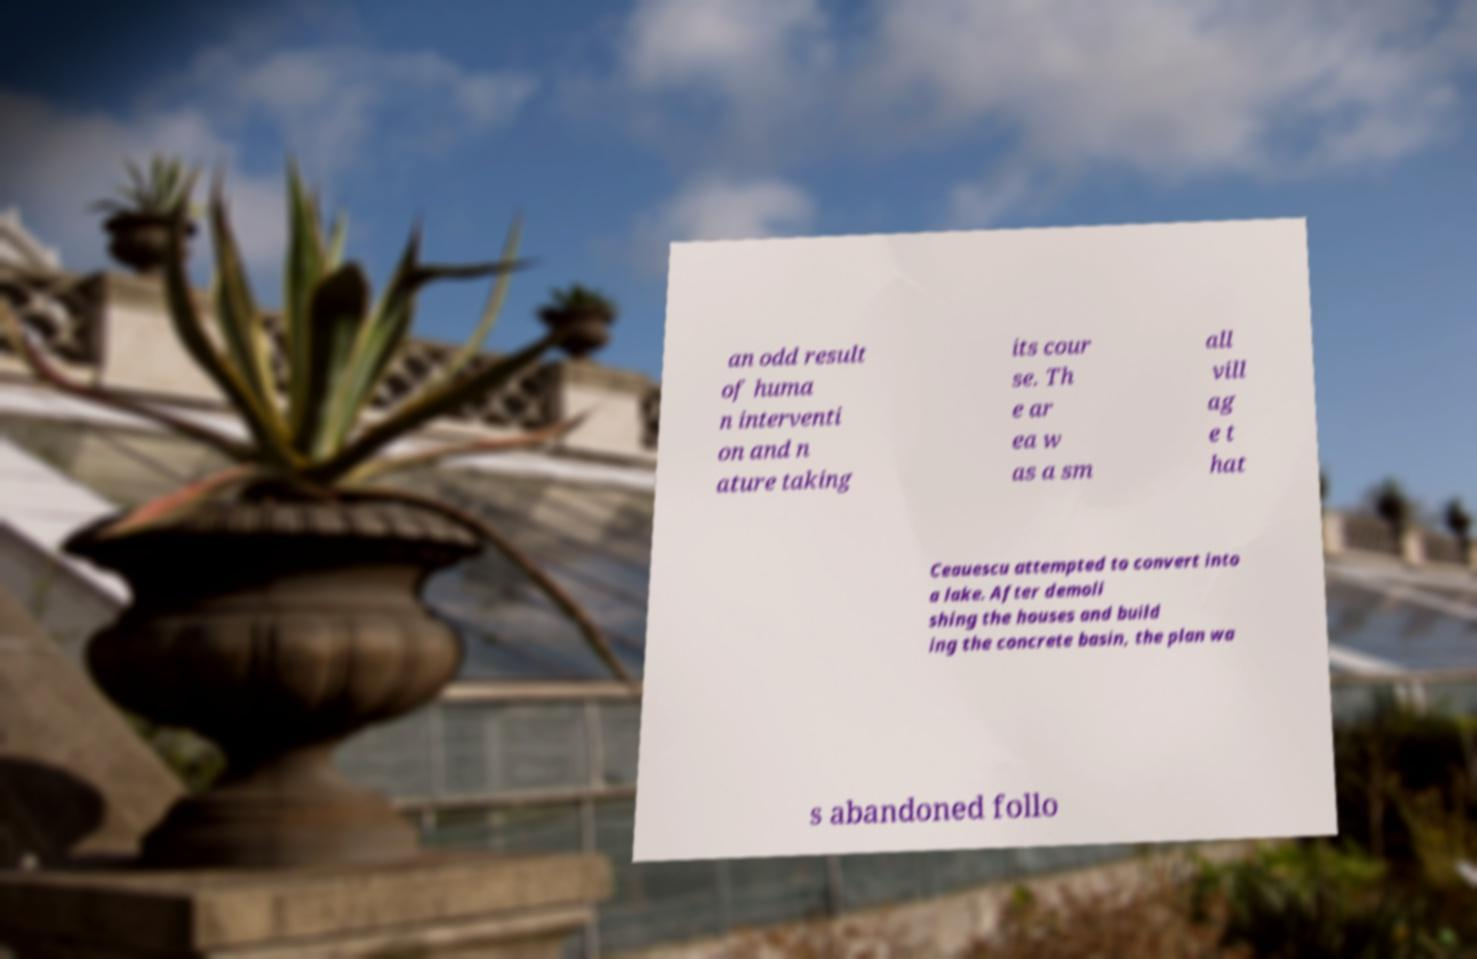Can you read and provide the text displayed in the image?This photo seems to have some interesting text. Can you extract and type it out for me? an odd result of huma n interventi on and n ature taking its cour se. Th e ar ea w as a sm all vill ag e t hat Ceauescu attempted to convert into a lake. After demoli shing the houses and build ing the concrete basin, the plan wa s abandoned follo 